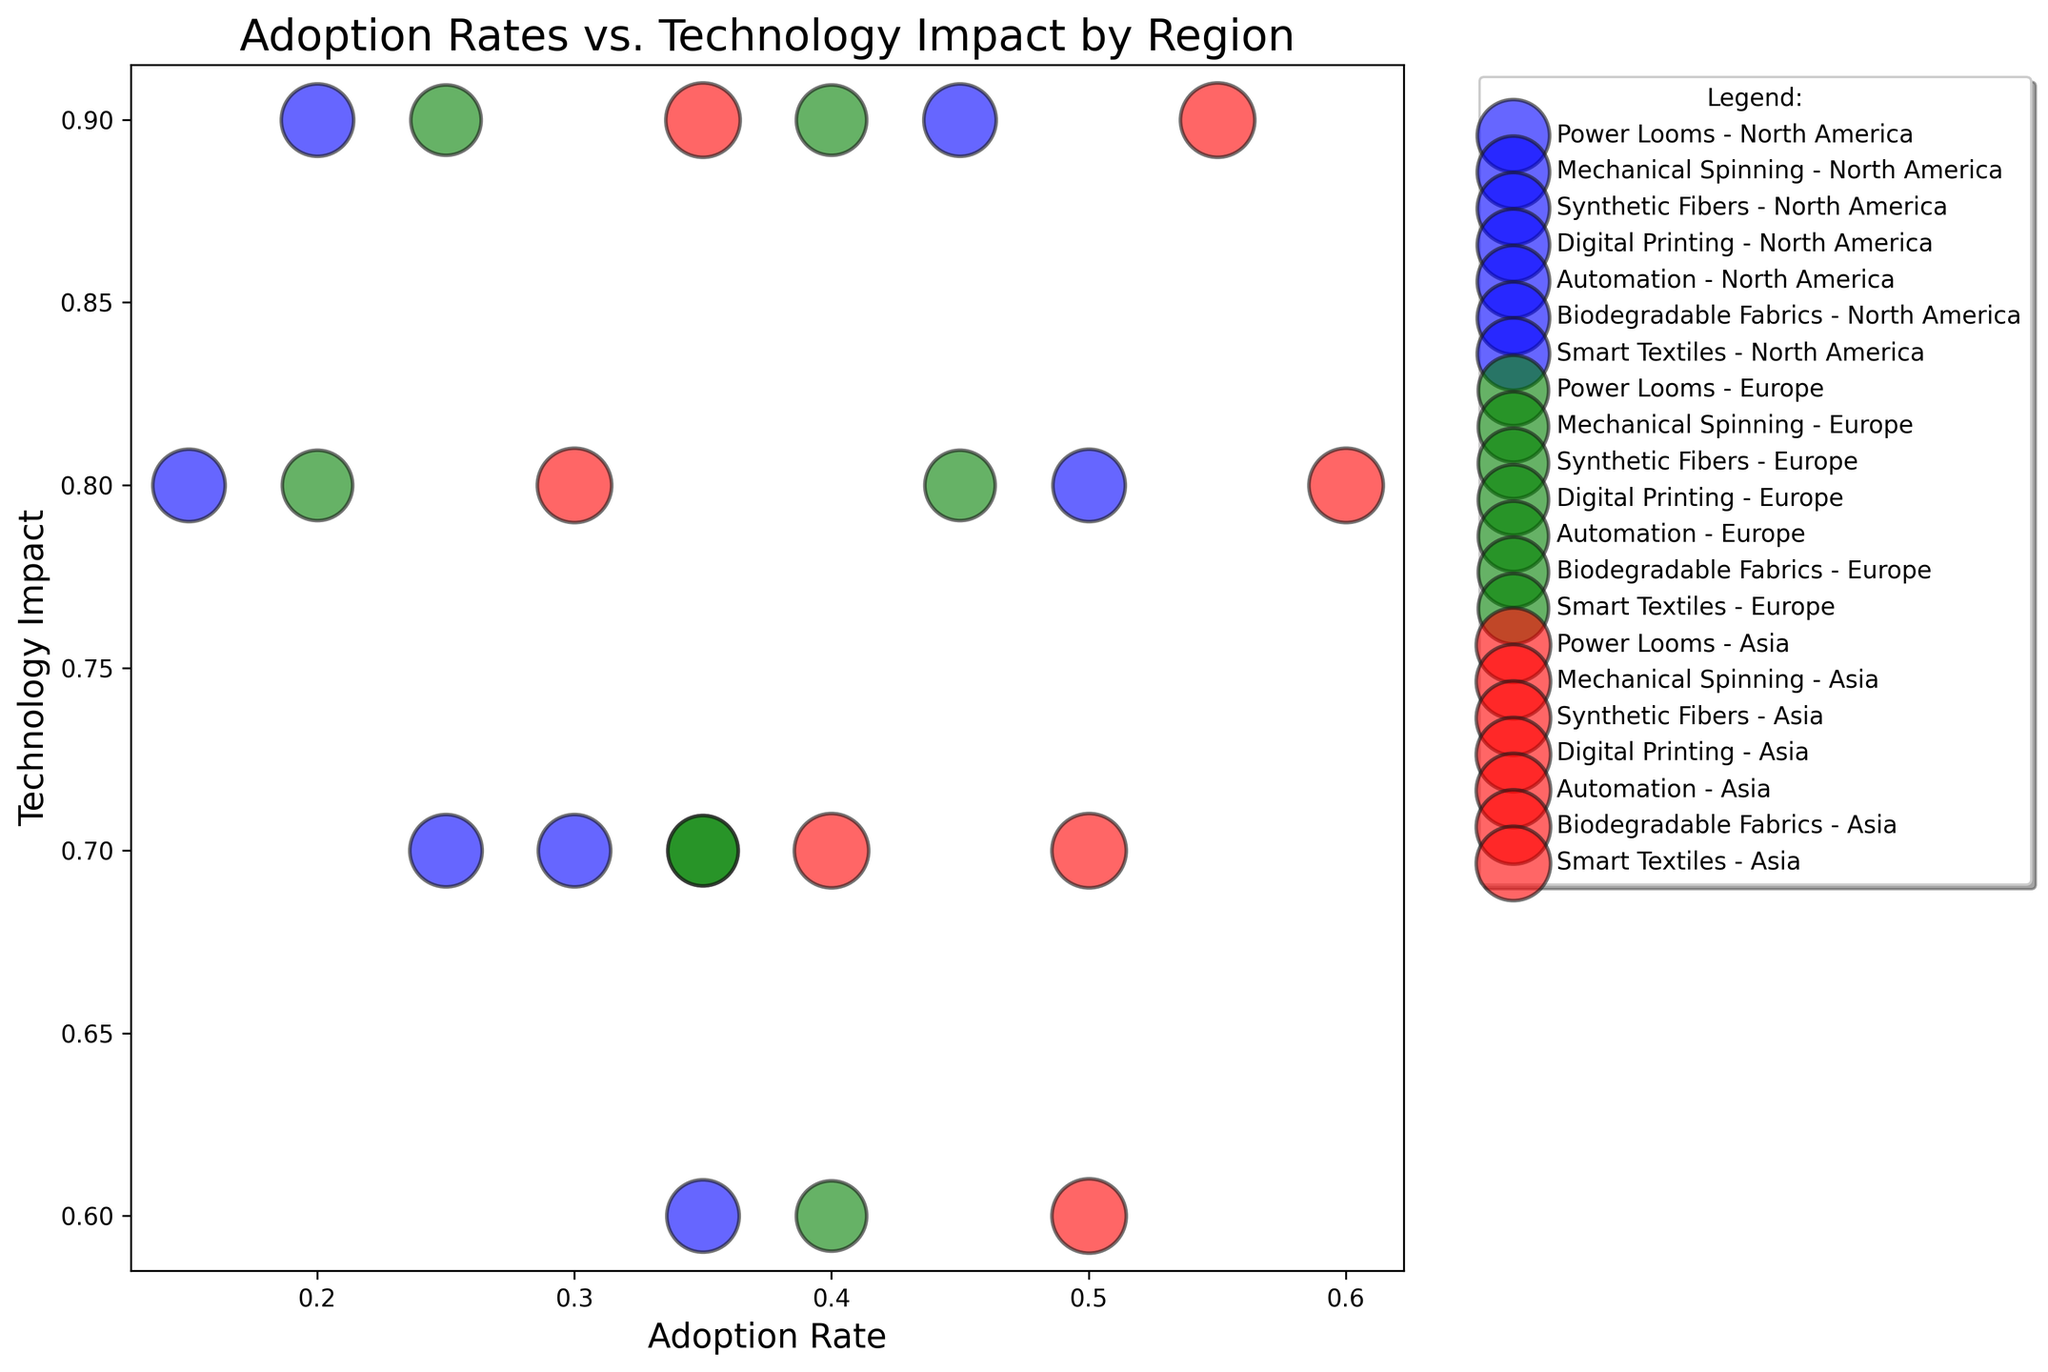What's the region with the highest adoption rate for Automation technology? Among the bubbles representing Automation technology, the largest horizontal position (adoption rate) is seen for Asia at 0.60.
Answer: Asia Which technology in North America has the lowest adoption rate? In North America, the bubble with the farthest left horizontal position from the technologies represented is Power Looms at 0.15.
Answer: Power Looms Compare the adoption rates of Mechanical Spinning in North America and Europe. Which has a higher rate and by how much? The adoption rate for Mechanical Spinning in North America is 0.25, and in Europe, it is 0.35. Therefore, Europe has a higher adoption rate by 0.10.
Answer: Europe, by 0.10 Which technology has the highest technology impact in Europe? The highest vertical position represents Synthetic Fibers, Digital Printing, and Smart Textiles at a technology impact of 0.9 in Europe.
Answer: Synthetic Fibers, Digital Printing, Smart Textiles How does the adoption rate of Synthetic Fibers in Asia compare to Digital Printing in the same region? In Asia, Synthetic Fibers have an adoption rate of 0.55, while Digital Printing has an adoption rate of 0.50. Therefore, Synthetic Fibers have a higher adoption rate by 0.05.
Answer: Synthetic Fibers, by 0.05 For which region and technology pair is the region importance highest? The largest bubble size indicates the highest region importance, which is observed in Asia across all technologies with values of 0.95.
Answer: Asia, all technologies Visualize the relative sizes of the bubbles representing Smart Textiles across regions. Which region has the largest bubble? The largest bubble size for Smart Textiles is in Asia, signifying the highest region importance.
Answer: Asia Which technology in North America has the highest adoption rate? The highest horizontal position for a North American technology is seen with Automation at 0.50.
Answer: Automation Sum up the adoption rates of Biodegradable Fabrics across all regions. The sum of the adoption rates of Biodegradable Fabrics in North America (0.30), Europe (0.35), and Asia (0.40) is 0.30 + 0.35 + 0.40 = 1.05.
Answer: 1.05 